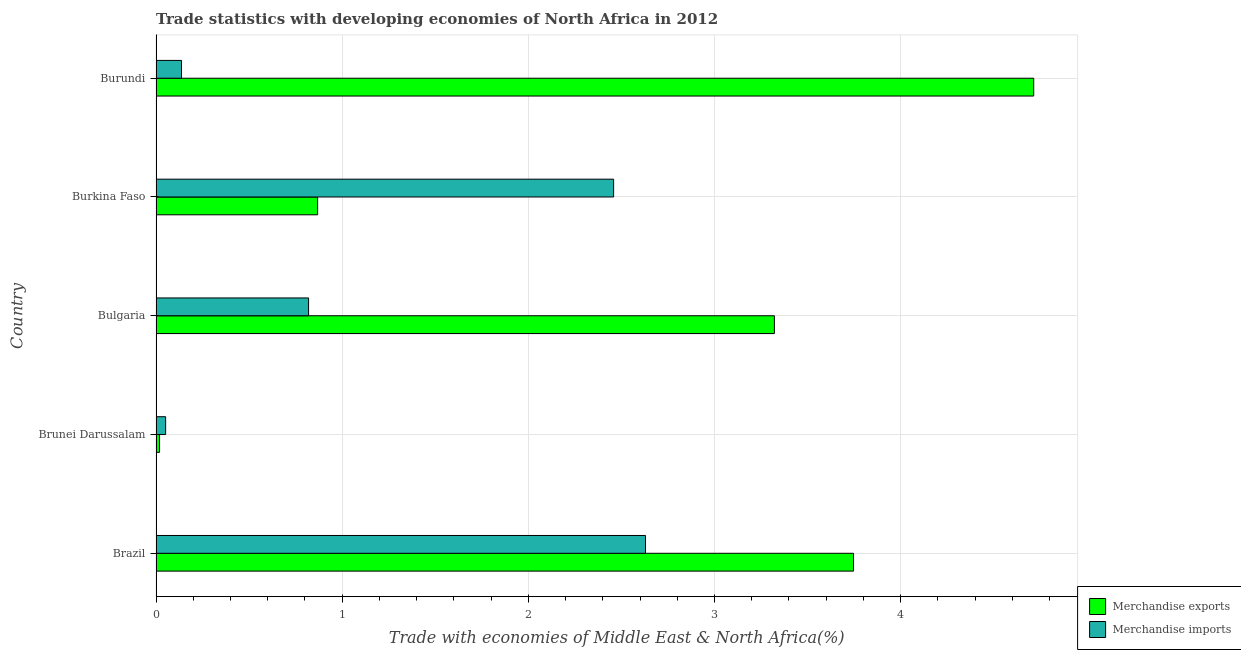How many different coloured bars are there?
Give a very brief answer. 2. How many bars are there on the 4th tick from the top?
Your answer should be compact. 2. How many bars are there on the 5th tick from the bottom?
Give a very brief answer. 2. What is the label of the 2nd group of bars from the top?
Provide a short and direct response. Burkina Faso. What is the merchandise imports in Burkina Faso?
Your response must be concise. 2.46. Across all countries, what is the maximum merchandise imports?
Offer a very short reply. 2.63. Across all countries, what is the minimum merchandise exports?
Make the answer very short. 0.02. In which country was the merchandise imports maximum?
Ensure brevity in your answer.  Brazil. In which country was the merchandise imports minimum?
Offer a terse response. Brunei Darussalam. What is the total merchandise exports in the graph?
Your answer should be compact. 12.67. What is the difference between the merchandise exports in Brunei Darussalam and that in Burkina Faso?
Your response must be concise. -0.85. What is the difference between the merchandise exports in Burundi and the merchandise imports in Brunei Darussalam?
Your answer should be compact. 4.66. What is the average merchandise imports per country?
Give a very brief answer. 1.22. What is the difference between the merchandise exports and merchandise imports in Brunei Darussalam?
Offer a terse response. -0.03. What is the ratio of the merchandise exports in Brazil to that in Brunei Darussalam?
Make the answer very short. 197.55. Is the merchandise exports in Brazil less than that in Burundi?
Offer a terse response. Yes. Is the difference between the merchandise imports in Bulgaria and Burkina Faso greater than the difference between the merchandise exports in Bulgaria and Burkina Faso?
Keep it short and to the point. No. What is the difference between the highest and the second highest merchandise exports?
Ensure brevity in your answer.  0.97. What is the difference between the highest and the lowest merchandise imports?
Give a very brief answer. 2.58. Is the sum of the merchandise exports in Brunei Darussalam and Bulgaria greater than the maximum merchandise imports across all countries?
Ensure brevity in your answer.  Yes. How many countries are there in the graph?
Offer a terse response. 5. Are the values on the major ticks of X-axis written in scientific E-notation?
Keep it short and to the point. No. Does the graph contain any zero values?
Your response must be concise. No. Does the graph contain grids?
Make the answer very short. Yes. Where does the legend appear in the graph?
Ensure brevity in your answer.  Bottom right. How are the legend labels stacked?
Provide a succinct answer. Vertical. What is the title of the graph?
Your response must be concise. Trade statistics with developing economies of North Africa in 2012. What is the label or title of the X-axis?
Offer a very short reply. Trade with economies of Middle East & North Africa(%). What is the label or title of the Y-axis?
Offer a very short reply. Country. What is the Trade with economies of Middle East & North Africa(%) of Merchandise exports in Brazil?
Provide a short and direct response. 3.75. What is the Trade with economies of Middle East & North Africa(%) in Merchandise imports in Brazil?
Your response must be concise. 2.63. What is the Trade with economies of Middle East & North Africa(%) of Merchandise exports in Brunei Darussalam?
Your answer should be compact. 0.02. What is the Trade with economies of Middle East & North Africa(%) in Merchandise imports in Brunei Darussalam?
Your answer should be very brief. 0.05. What is the Trade with economies of Middle East & North Africa(%) of Merchandise exports in Bulgaria?
Your response must be concise. 3.32. What is the Trade with economies of Middle East & North Africa(%) of Merchandise imports in Bulgaria?
Make the answer very short. 0.82. What is the Trade with economies of Middle East & North Africa(%) of Merchandise exports in Burkina Faso?
Keep it short and to the point. 0.87. What is the Trade with economies of Middle East & North Africa(%) of Merchandise imports in Burkina Faso?
Your answer should be compact. 2.46. What is the Trade with economies of Middle East & North Africa(%) of Merchandise exports in Burundi?
Provide a short and direct response. 4.71. What is the Trade with economies of Middle East & North Africa(%) of Merchandise imports in Burundi?
Make the answer very short. 0.14. Across all countries, what is the maximum Trade with economies of Middle East & North Africa(%) of Merchandise exports?
Keep it short and to the point. 4.71. Across all countries, what is the maximum Trade with economies of Middle East & North Africa(%) of Merchandise imports?
Give a very brief answer. 2.63. Across all countries, what is the minimum Trade with economies of Middle East & North Africa(%) in Merchandise exports?
Offer a terse response. 0.02. Across all countries, what is the minimum Trade with economies of Middle East & North Africa(%) in Merchandise imports?
Make the answer very short. 0.05. What is the total Trade with economies of Middle East & North Africa(%) in Merchandise exports in the graph?
Offer a terse response. 12.67. What is the total Trade with economies of Middle East & North Africa(%) in Merchandise imports in the graph?
Provide a succinct answer. 6.1. What is the difference between the Trade with economies of Middle East & North Africa(%) in Merchandise exports in Brazil and that in Brunei Darussalam?
Your answer should be compact. 3.73. What is the difference between the Trade with economies of Middle East & North Africa(%) of Merchandise imports in Brazil and that in Brunei Darussalam?
Your answer should be compact. 2.58. What is the difference between the Trade with economies of Middle East & North Africa(%) in Merchandise exports in Brazil and that in Bulgaria?
Your answer should be compact. 0.42. What is the difference between the Trade with economies of Middle East & North Africa(%) of Merchandise imports in Brazil and that in Bulgaria?
Provide a short and direct response. 1.81. What is the difference between the Trade with economies of Middle East & North Africa(%) of Merchandise exports in Brazil and that in Burkina Faso?
Ensure brevity in your answer.  2.88. What is the difference between the Trade with economies of Middle East & North Africa(%) in Merchandise imports in Brazil and that in Burkina Faso?
Keep it short and to the point. 0.17. What is the difference between the Trade with economies of Middle East & North Africa(%) of Merchandise exports in Brazil and that in Burundi?
Ensure brevity in your answer.  -0.97. What is the difference between the Trade with economies of Middle East & North Africa(%) in Merchandise imports in Brazil and that in Burundi?
Offer a very short reply. 2.49. What is the difference between the Trade with economies of Middle East & North Africa(%) in Merchandise exports in Brunei Darussalam and that in Bulgaria?
Offer a terse response. -3.3. What is the difference between the Trade with economies of Middle East & North Africa(%) in Merchandise imports in Brunei Darussalam and that in Bulgaria?
Offer a terse response. -0.77. What is the difference between the Trade with economies of Middle East & North Africa(%) of Merchandise exports in Brunei Darussalam and that in Burkina Faso?
Your response must be concise. -0.85. What is the difference between the Trade with economies of Middle East & North Africa(%) of Merchandise imports in Brunei Darussalam and that in Burkina Faso?
Offer a terse response. -2.41. What is the difference between the Trade with economies of Middle East & North Africa(%) in Merchandise exports in Brunei Darussalam and that in Burundi?
Provide a succinct answer. -4.7. What is the difference between the Trade with economies of Middle East & North Africa(%) in Merchandise imports in Brunei Darussalam and that in Burundi?
Your answer should be very brief. -0.09. What is the difference between the Trade with economies of Middle East & North Africa(%) of Merchandise exports in Bulgaria and that in Burkina Faso?
Offer a terse response. 2.45. What is the difference between the Trade with economies of Middle East & North Africa(%) in Merchandise imports in Bulgaria and that in Burkina Faso?
Provide a short and direct response. -1.64. What is the difference between the Trade with economies of Middle East & North Africa(%) of Merchandise exports in Bulgaria and that in Burundi?
Offer a very short reply. -1.39. What is the difference between the Trade with economies of Middle East & North Africa(%) in Merchandise imports in Bulgaria and that in Burundi?
Your answer should be very brief. 0.68. What is the difference between the Trade with economies of Middle East & North Africa(%) in Merchandise exports in Burkina Faso and that in Burundi?
Provide a succinct answer. -3.85. What is the difference between the Trade with economies of Middle East & North Africa(%) in Merchandise imports in Burkina Faso and that in Burundi?
Your answer should be compact. 2.32. What is the difference between the Trade with economies of Middle East & North Africa(%) of Merchandise exports in Brazil and the Trade with economies of Middle East & North Africa(%) of Merchandise imports in Brunei Darussalam?
Make the answer very short. 3.69. What is the difference between the Trade with economies of Middle East & North Africa(%) of Merchandise exports in Brazil and the Trade with economies of Middle East & North Africa(%) of Merchandise imports in Bulgaria?
Your answer should be very brief. 2.93. What is the difference between the Trade with economies of Middle East & North Africa(%) in Merchandise exports in Brazil and the Trade with economies of Middle East & North Africa(%) in Merchandise imports in Burkina Faso?
Your response must be concise. 1.29. What is the difference between the Trade with economies of Middle East & North Africa(%) in Merchandise exports in Brazil and the Trade with economies of Middle East & North Africa(%) in Merchandise imports in Burundi?
Your answer should be very brief. 3.61. What is the difference between the Trade with economies of Middle East & North Africa(%) in Merchandise exports in Brunei Darussalam and the Trade with economies of Middle East & North Africa(%) in Merchandise imports in Bulgaria?
Offer a very short reply. -0.8. What is the difference between the Trade with economies of Middle East & North Africa(%) of Merchandise exports in Brunei Darussalam and the Trade with economies of Middle East & North Africa(%) of Merchandise imports in Burkina Faso?
Make the answer very short. -2.44. What is the difference between the Trade with economies of Middle East & North Africa(%) of Merchandise exports in Brunei Darussalam and the Trade with economies of Middle East & North Africa(%) of Merchandise imports in Burundi?
Provide a succinct answer. -0.12. What is the difference between the Trade with economies of Middle East & North Africa(%) of Merchandise exports in Bulgaria and the Trade with economies of Middle East & North Africa(%) of Merchandise imports in Burkina Faso?
Provide a succinct answer. 0.86. What is the difference between the Trade with economies of Middle East & North Africa(%) in Merchandise exports in Bulgaria and the Trade with economies of Middle East & North Africa(%) in Merchandise imports in Burundi?
Provide a short and direct response. 3.18. What is the difference between the Trade with economies of Middle East & North Africa(%) of Merchandise exports in Burkina Faso and the Trade with economies of Middle East & North Africa(%) of Merchandise imports in Burundi?
Offer a terse response. 0.73. What is the average Trade with economies of Middle East & North Africa(%) in Merchandise exports per country?
Offer a terse response. 2.53. What is the average Trade with economies of Middle East & North Africa(%) in Merchandise imports per country?
Provide a short and direct response. 1.22. What is the difference between the Trade with economies of Middle East & North Africa(%) in Merchandise exports and Trade with economies of Middle East & North Africa(%) in Merchandise imports in Brazil?
Provide a short and direct response. 1.12. What is the difference between the Trade with economies of Middle East & North Africa(%) in Merchandise exports and Trade with economies of Middle East & North Africa(%) in Merchandise imports in Brunei Darussalam?
Offer a very short reply. -0.03. What is the difference between the Trade with economies of Middle East & North Africa(%) in Merchandise exports and Trade with economies of Middle East & North Africa(%) in Merchandise imports in Bulgaria?
Offer a terse response. 2.5. What is the difference between the Trade with economies of Middle East & North Africa(%) in Merchandise exports and Trade with economies of Middle East & North Africa(%) in Merchandise imports in Burkina Faso?
Offer a terse response. -1.59. What is the difference between the Trade with economies of Middle East & North Africa(%) in Merchandise exports and Trade with economies of Middle East & North Africa(%) in Merchandise imports in Burundi?
Offer a terse response. 4.58. What is the ratio of the Trade with economies of Middle East & North Africa(%) in Merchandise exports in Brazil to that in Brunei Darussalam?
Keep it short and to the point. 197.55. What is the ratio of the Trade with economies of Middle East & North Africa(%) of Merchandise imports in Brazil to that in Brunei Darussalam?
Give a very brief answer. 50.85. What is the ratio of the Trade with economies of Middle East & North Africa(%) of Merchandise exports in Brazil to that in Bulgaria?
Ensure brevity in your answer.  1.13. What is the ratio of the Trade with economies of Middle East & North Africa(%) of Merchandise imports in Brazil to that in Bulgaria?
Provide a short and direct response. 3.21. What is the ratio of the Trade with economies of Middle East & North Africa(%) of Merchandise exports in Brazil to that in Burkina Faso?
Offer a very short reply. 4.32. What is the ratio of the Trade with economies of Middle East & North Africa(%) of Merchandise imports in Brazil to that in Burkina Faso?
Keep it short and to the point. 1.07. What is the ratio of the Trade with economies of Middle East & North Africa(%) of Merchandise exports in Brazil to that in Burundi?
Offer a very short reply. 0.79. What is the ratio of the Trade with economies of Middle East & North Africa(%) in Merchandise imports in Brazil to that in Burundi?
Your response must be concise. 19.2. What is the ratio of the Trade with economies of Middle East & North Africa(%) of Merchandise exports in Brunei Darussalam to that in Bulgaria?
Your answer should be compact. 0.01. What is the ratio of the Trade with economies of Middle East & North Africa(%) of Merchandise imports in Brunei Darussalam to that in Bulgaria?
Offer a terse response. 0.06. What is the ratio of the Trade with economies of Middle East & North Africa(%) of Merchandise exports in Brunei Darussalam to that in Burkina Faso?
Make the answer very short. 0.02. What is the ratio of the Trade with economies of Middle East & North Africa(%) in Merchandise imports in Brunei Darussalam to that in Burkina Faso?
Offer a very short reply. 0.02. What is the ratio of the Trade with economies of Middle East & North Africa(%) of Merchandise exports in Brunei Darussalam to that in Burundi?
Your answer should be compact. 0. What is the ratio of the Trade with economies of Middle East & North Africa(%) of Merchandise imports in Brunei Darussalam to that in Burundi?
Your answer should be compact. 0.38. What is the ratio of the Trade with economies of Middle East & North Africa(%) of Merchandise exports in Bulgaria to that in Burkina Faso?
Your response must be concise. 3.83. What is the ratio of the Trade with economies of Middle East & North Africa(%) in Merchandise imports in Bulgaria to that in Burkina Faso?
Make the answer very short. 0.33. What is the ratio of the Trade with economies of Middle East & North Africa(%) in Merchandise exports in Bulgaria to that in Burundi?
Your answer should be very brief. 0.7. What is the ratio of the Trade with economies of Middle East & North Africa(%) in Merchandise imports in Bulgaria to that in Burundi?
Provide a short and direct response. 5.99. What is the ratio of the Trade with economies of Middle East & North Africa(%) of Merchandise exports in Burkina Faso to that in Burundi?
Your answer should be compact. 0.18. What is the ratio of the Trade with economies of Middle East & North Africa(%) of Merchandise imports in Burkina Faso to that in Burundi?
Offer a very short reply. 17.95. What is the difference between the highest and the second highest Trade with economies of Middle East & North Africa(%) of Merchandise imports?
Offer a very short reply. 0.17. What is the difference between the highest and the lowest Trade with economies of Middle East & North Africa(%) in Merchandise exports?
Provide a succinct answer. 4.7. What is the difference between the highest and the lowest Trade with economies of Middle East & North Africa(%) of Merchandise imports?
Your response must be concise. 2.58. 